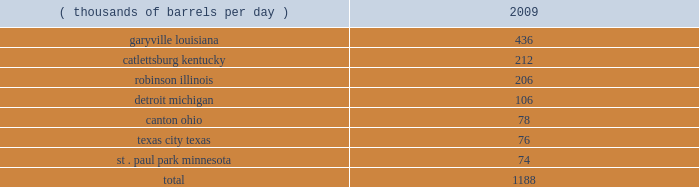Technical and research personnel and lab facilities , and significantly expanded the portfolio of patents available to us via license and through a cooperative development program .
In addition , we have acquired a 20 percent interest in grt , inc .
The gtftm technology is protected by an intellectual property protection program .
The u.s .
Has granted 17 patents for the technology , with another 22 pending .
Worldwide , there are over 300 patents issued or pending , covering over 100 countries including regional and direct foreign filings .
Another innovative technology that we are developing focuses on reducing the processing and transportation costs of natural gas by artificially creating natural gas hydrates , which are more easily transportable than natural gas in its gaseous form .
Much like lng , gas hydrates would then be regasified upon delivery to the receiving market .
We have an active pilot program in place to test and further develop a proprietary natural gas hydrates manufacturing system .
The above discussion of the integrated gas segment contains forward-looking statements with respect to the possible expansion of the lng production facility .
Factors that could potentially affect the possible expansion of the lng production facility include partner and government approvals , access to sufficient natural gas volumes through exploration or commercial negotiations with other resource owners and access to sufficient regasification capacity .
The foregoing factors ( among others ) could cause actual results to differ materially from those set forth in the forward-looking statements .
Refining , marketing and transportation we have refining , marketing and transportation operations concentrated primarily in the midwest , upper great plains , gulf coast and southeast regions of the u.s .
We rank as the fifth largest crude oil refiner in the u.s .
And the largest in the midwest .
Our operations include a seven-plant refining network and an integrated terminal and transportation system which supplies wholesale and marathon-brand customers as well as our own retail operations .
Our wholly-owned retail marketing subsidiary speedway superamerica llc ( 201cssa 201d ) is the third largest chain of company-owned and -operated retail gasoline and convenience stores in the u.s .
And the largest in the midwest .
Refining we own and operate seven refineries with an aggregate refining capacity of 1.188 million barrels per day ( 201cmmbpd 201d ) of crude oil as of december 31 , 2009 .
During 2009 , our refineries processed 957 mbpd of crude oil and 196 mbpd of other charge and blend stocks .
The table below sets forth the location and daily crude oil refining capacity of each of our refineries as of december 31 , 2009 .
Crude oil refining capacity ( thousands of barrels per day ) 2009 .
Our refineries include crude oil atmospheric and vacuum distillation , fluid catalytic cracking , catalytic reforming , desulfurization and sulfur recovery units .
The refineries process a wide variety of crude oils and produce numerous refined products , ranging from transportation fuels , such as reformulated gasolines , blend- grade gasolines intended for blending with fuel ethanol and ultra-low sulfur diesel fuel , to heavy fuel oil and asphalt .
Additionally , we manufacture aromatics , cumene , propane , propylene , sulfur and maleic anhydride .
Our garyville , louisiana , refinery is located along the mississippi river in southeastern louisiana between new orleans and baton rouge .
The garyville refinery predominantly processes heavy sour crude oil into products .
Did the refineries in detroit michigan process more crude than those in canton ohio? 
Computations: (106 > 78)
Answer: yes. 